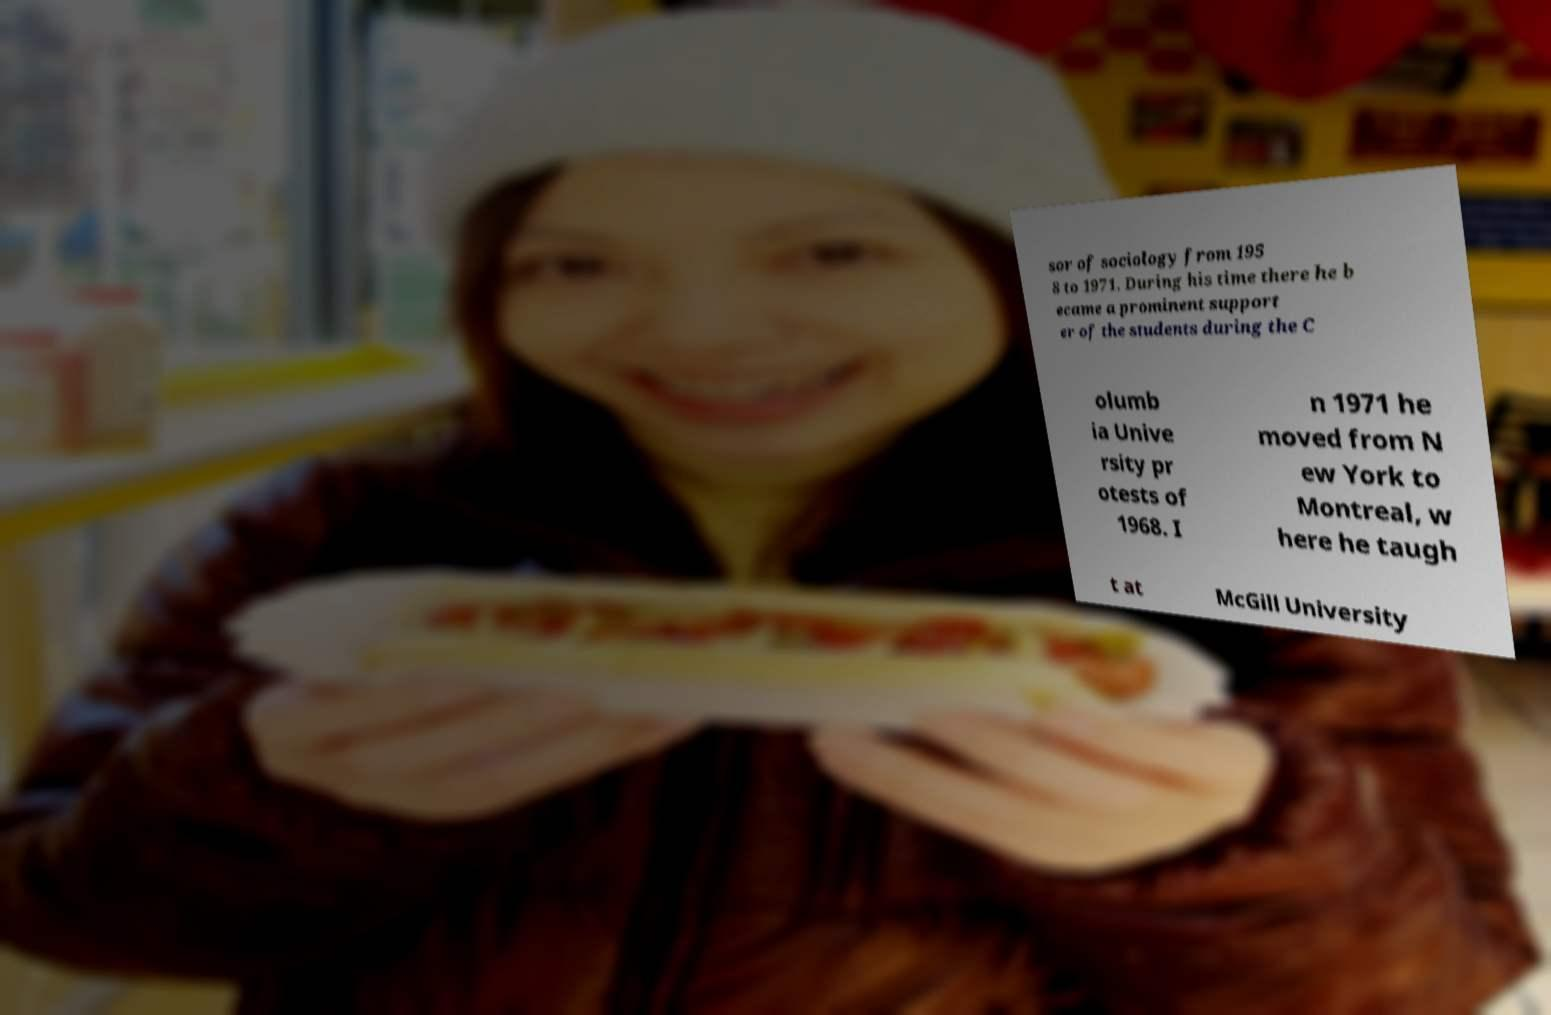Could you assist in decoding the text presented in this image and type it out clearly? sor of sociology from 195 8 to 1971. During his time there he b ecame a prominent support er of the students during the C olumb ia Unive rsity pr otests of 1968. I n 1971 he moved from N ew York to Montreal, w here he taugh t at McGill University 